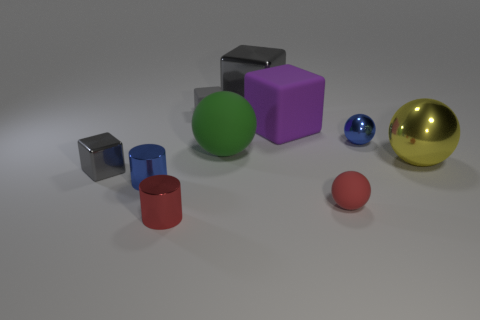Subtract all big purple cubes. How many cubes are left? 3 Subtract 1 cylinders. How many cylinders are left? 1 Subtract all red cylinders. How many cylinders are left? 1 Subtract all gray objects. Subtract all small gray matte things. How many objects are left? 6 Add 2 tiny blue shiny cylinders. How many tiny blue shiny cylinders are left? 3 Add 6 small red matte things. How many small red matte things exist? 7 Subtract 0 green cylinders. How many objects are left? 10 Subtract all blocks. How many objects are left? 6 Subtract all red cubes. Subtract all purple cylinders. How many cubes are left? 4 Subtract all cyan balls. How many red cylinders are left? 1 